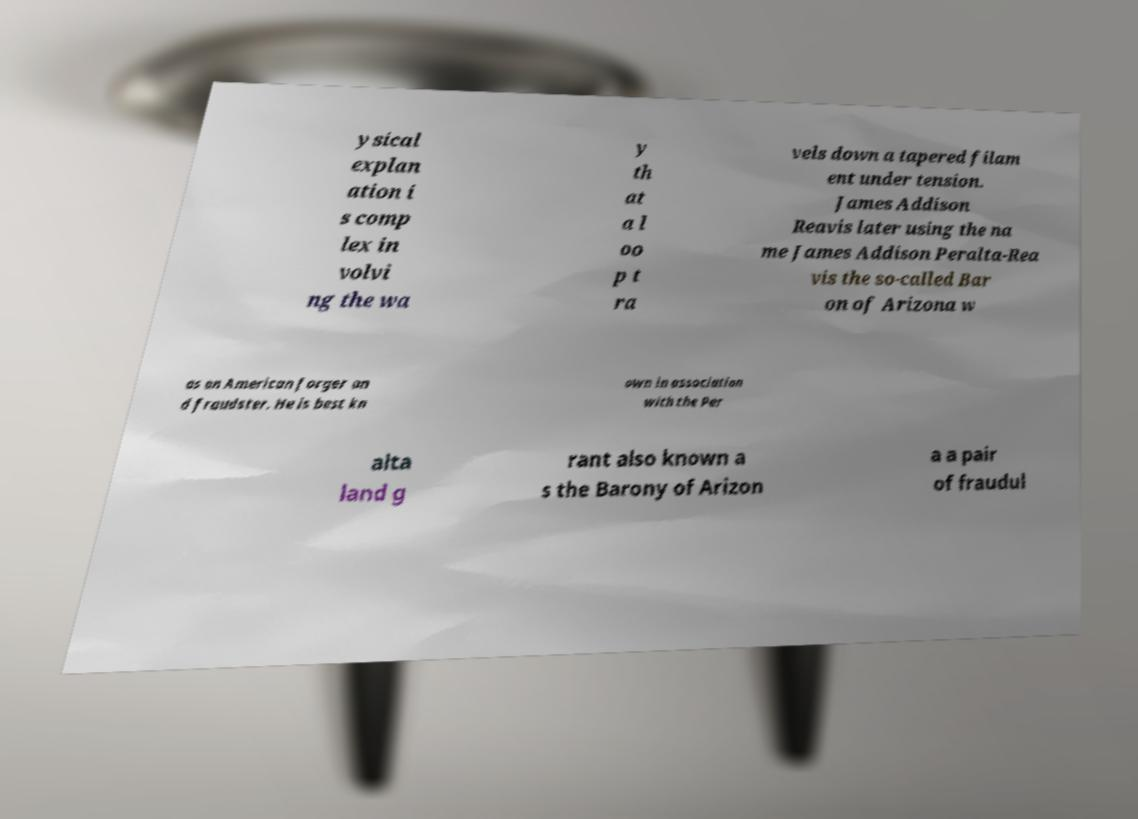Could you extract and type out the text from this image? ysical explan ation i s comp lex in volvi ng the wa y th at a l oo p t ra vels down a tapered filam ent under tension. James Addison Reavis later using the na me James Addison Peralta-Rea vis the so-called Bar on of Arizona w as an American forger an d fraudster. He is best kn own in association with the Per alta land g rant also known a s the Barony of Arizon a a pair of fraudul 